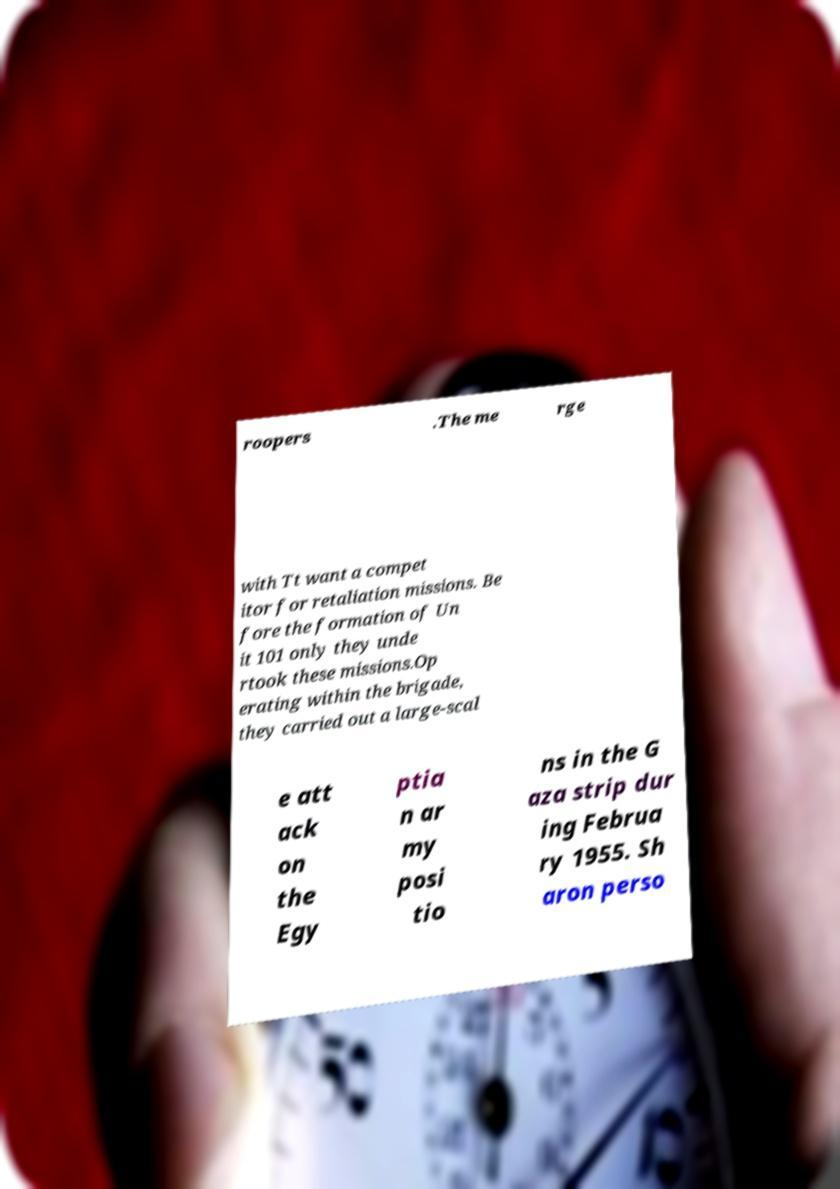Can you accurately transcribe the text from the provided image for me? roopers .The me rge with Tt want a compet itor for retaliation missions. Be fore the formation of Un it 101 only they unde rtook these missions.Op erating within the brigade, they carried out a large-scal e att ack on the Egy ptia n ar my posi tio ns in the G aza strip dur ing Februa ry 1955. Sh aron perso 